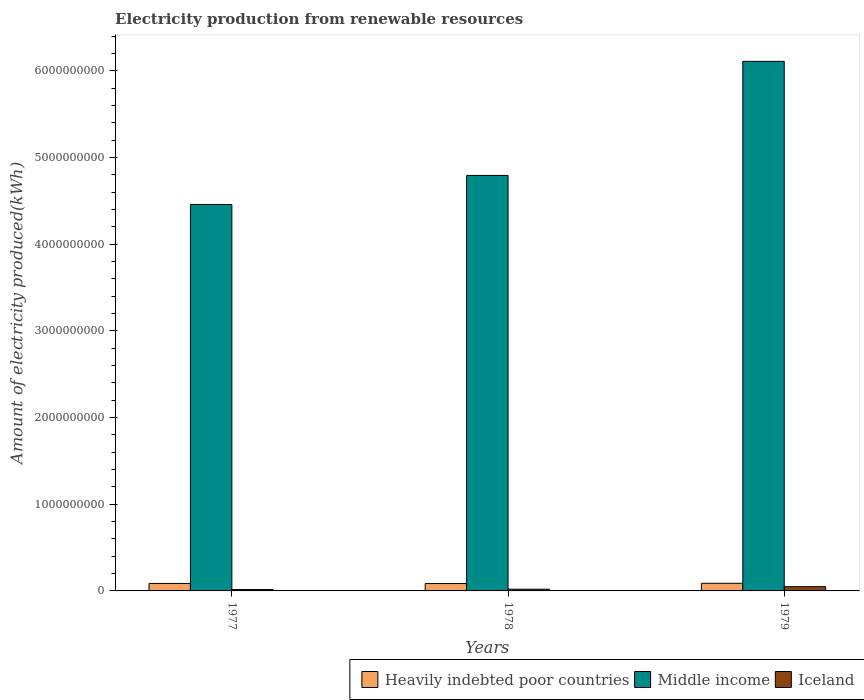What is the amount of electricity produced in Middle income in 1978?
Give a very brief answer. 4.79e+09. Across all years, what is the maximum amount of electricity produced in Iceland?
Provide a short and direct response. 4.90e+07. Across all years, what is the minimum amount of electricity produced in Middle income?
Your answer should be compact. 4.46e+09. In which year was the amount of electricity produced in Heavily indebted poor countries maximum?
Ensure brevity in your answer.  1979. In which year was the amount of electricity produced in Middle income minimum?
Ensure brevity in your answer.  1977. What is the total amount of electricity produced in Iceland in the graph?
Provide a succinct answer. 8.50e+07. What is the difference between the amount of electricity produced in Middle income in 1977 and that in 1979?
Give a very brief answer. -1.65e+09. What is the difference between the amount of electricity produced in Iceland in 1978 and the amount of electricity produced in Middle income in 1979?
Give a very brief answer. -6.09e+09. What is the average amount of electricity produced in Heavily indebted poor countries per year?
Your answer should be very brief. 8.63e+07. In the year 1979, what is the difference between the amount of electricity produced in Middle income and amount of electricity produced in Iceland?
Your answer should be very brief. 6.06e+09. What is the ratio of the amount of electricity produced in Heavily indebted poor countries in 1978 to that in 1979?
Provide a succinct answer. 0.97. Is the amount of electricity produced in Heavily indebted poor countries in 1978 less than that in 1979?
Provide a succinct answer. Yes. What is the difference between the highest and the second highest amount of electricity produced in Heavily indebted poor countries?
Offer a very short reply. 2.00e+06. What is the difference between the highest and the lowest amount of electricity produced in Iceland?
Your response must be concise. 3.30e+07. What does the 1st bar from the left in 1977 represents?
Offer a terse response. Heavily indebted poor countries. Is it the case that in every year, the sum of the amount of electricity produced in Iceland and amount of electricity produced in Heavily indebted poor countries is greater than the amount of electricity produced in Middle income?
Make the answer very short. No. Are all the bars in the graph horizontal?
Give a very brief answer. No. What is the difference between two consecutive major ticks on the Y-axis?
Offer a very short reply. 1.00e+09. Does the graph contain any zero values?
Provide a short and direct response. No. Does the graph contain grids?
Your answer should be compact. No. Where does the legend appear in the graph?
Your answer should be compact. Bottom right. How are the legend labels stacked?
Provide a succinct answer. Horizontal. What is the title of the graph?
Keep it short and to the point. Electricity production from renewable resources. What is the label or title of the Y-axis?
Offer a very short reply. Amount of electricity produced(kWh). What is the Amount of electricity produced(kWh) of Heavily indebted poor countries in 1977?
Offer a terse response. 8.60e+07. What is the Amount of electricity produced(kWh) of Middle income in 1977?
Make the answer very short. 4.46e+09. What is the Amount of electricity produced(kWh) of Iceland in 1977?
Make the answer very short. 1.60e+07. What is the Amount of electricity produced(kWh) in Heavily indebted poor countries in 1978?
Ensure brevity in your answer.  8.50e+07. What is the Amount of electricity produced(kWh) of Middle income in 1978?
Your answer should be very brief. 4.79e+09. What is the Amount of electricity produced(kWh) of Heavily indebted poor countries in 1979?
Your answer should be very brief. 8.80e+07. What is the Amount of electricity produced(kWh) in Middle income in 1979?
Ensure brevity in your answer.  6.11e+09. What is the Amount of electricity produced(kWh) in Iceland in 1979?
Make the answer very short. 4.90e+07. Across all years, what is the maximum Amount of electricity produced(kWh) in Heavily indebted poor countries?
Keep it short and to the point. 8.80e+07. Across all years, what is the maximum Amount of electricity produced(kWh) in Middle income?
Your answer should be compact. 6.11e+09. Across all years, what is the maximum Amount of electricity produced(kWh) in Iceland?
Provide a short and direct response. 4.90e+07. Across all years, what is the minimum Amount of electricity produced(kWh) in Heavily indebted poor countries?
Keep it short and to the point. 8.50e+07. Across all years, what is the minimum Amount of electricity produced(kWh) in Middle income?
Give a very brief answer. 4.46e+09. Across all years, what is the minimum Amount of electricity produced(kWh) in Iceland?
Provide a succinct answer. 1.60e+07. What is the total Amount of electricity produced(kWh) in Heavily indebted poor countries in the graph?
Your answer should be compact. 2.59e+08. What is the total Amount of electricity produced(kWh) in Middle income in the graph?
Make the answer very short. 1.54e+1. What is the total Amount of electricity produced(kWh) of Iceland in the graph?
Your answer should be compact. 8.50e+07. What is the difference between the Amount of electricity produced(kWh) in Middle income in 1977 and that in 1978?
Your answer should be compact. -3.35e+08. What is the difference between the Amount of electricity produced(kWh) in Heavily indebted poor countries in 1977 and that in 1979?
Provide a short and direct response. -2.00e+06. What is the difference between the Amount of electricity produced(kWh) of Middle income in 1977 and that in 1979?
Your answer should be very brief. -1.65e+09. What is the difference between the Amount of electricity produced(kWh) in Iceland in 1977 and that in 1979?
Offer a terse response. -3.30e+07. What is the difference between the Amount of electricity produced(kWh) of Middle income in 1978 and that in 1979?
Keep it short and to the point. -1.32e+09. What is the difference between the Amount of electricity produced(kWh) of Iceland in 1978 and that in 1979?
Your answer should be very brief. -2.90e+07. What is the difference between the Amount of electricity produced(kWh) of Heavily indebted poor countries in 1977 and the Amount of electricity produced(kWh) of Middle income in 1978?
Provide a short and direct response. -4.71e+09. What is the difference between the Amount of electricity produced(kWh) of Heavily indebted poor countries in 1977 and the Amount of electricity produced(kWh) of Iceland in 1978?
Offer a very short reply. 6.60e+07. What is the difference between the Amount of electricity produced(kWh) in Middle income in 1977 and the Amount of electricity produced(kWh) in Iceland in 1978?
Ensure brevity in your answer.  4.44e+09. What is the difference between the Amount of electricity produced(kWh) of Heavily indebted poor countries in 1977 and the Amount of electricity produced(kWh) of Middle income in 1979?
Offer a terse response. -6.02e+09. What is the difference between the Amount of electricity produced(kWh) in Heavily indebted poor countries in 1977 and the Amount of electricity produced(kWh) in Iceland in 1979?
Provide a succinct answer. 3.70e+07. What is the difference between the Amount of electricity produced(kWh) in Middle income in 1977 and the Amount of electricity produced(kWh) in Iceland in 1979?
Provide a succinct answer. 4.41e+09. What is the difference between the Amount of electricity produced(kWh) in Heavily indebted poor countries in 1978 and the Amount of electricity produced(kWh) in Middle income in 1979?
Make the answer very short. -6.02e+09. What is the difference between the Amount of electricity produced(kWh) of Heavily indebted poor countries in 1978 and the Amount of electricity produced(kWh) of Iceland in 1979?
Offer a very short reply. 3.60e+07. What is the difference between the Amount of electricity produced(kWh) in Middle income in 1978 and the Amount of electricity produced(kWh) in Iceland in 1979?
Ensure brevity in your answer.  4.74e+09. What is the average Amount of electricity produced(kWh) of Heavily indebted poor countries per year?
Keep it short and to the point. 8.63e+07. What is the average Amount of electricity produced(kWh) of Middle income per year?
Your response must be concise. 5.12e+09. What is the average Amount of electricity produced(kWh) in Iceland per year?
Your answer should be compact. 2.83e+07. In the year 1977, what is the difference between the Amount of electricity produced(kWh) in Heavily indebted poor countries and Amount of electricity produced(kWh) in Middle income?
Keep it short and to the point. -4.37e+09. In the year 1977, what is the difference between the Amount of electricity produced(kWh) in Heavily indebted poor countries and Amount of electricity produced(kWh) in Iceland?
Provide a succinct answer. 7.00e+07. In the year 1977, what is the difference between the Amount of electricity produced(kWh) in Middle income and Amount of electricity produced(kWh) in Iceland?
Ensure brevity in your answer.  4.44e+09. In the year 1978, what is the difference between the Amount of electricity produced(kWh) of Heavily indebted poor countries and Amount of electricity produced(kWh) of Middle income?
Your response must be concise. -4.71e+09. In the year 1978, what is the difference between the Amount of electricity produced(kWh) of Heavily indebted poor countries and Amount of electricity produced(kWh) of Iceland?
Your answer should be very brief. 6.50e+07. In the year 1978, what is the difference between the Amount of electricity produced(kWh) in Middle income and Amount of electricity produced(kWh) in Iceland?
Ensure brevity in your answer.  4.77e+09. In the year 1979, what is the difference between the Amount of electricity produced(kWh) in Heavily indebted poor countries and Amount of electricity produced(kWh) in Middle income?
Offer a very short reply. -6.02e+09. In the year 1979, what is the difference between the Amount of electricity produced(kWh) in Heavily indebted poor countries and Amount of electricity produced(kWh) in Iceland?
Give a very brief answer. 3.90e+07. In the year 1979, what is the difference between the Amount of electricity produced(kWh) of Middle income and Amount of electricity produced(kWh) of Iceland?
Keep it short and to the point. 6.06e+09. What is the ratio of the Amount of electricity produced(kWh) in Heavily indebted poor countries in 1977 to that in 1978?
Ensure brevity in your answer.  1.01. What is the ratio of the Amount of electricity produced(kWh) in Middle income in 1977 to that in 1978?
Provide a succinct answer. 0.93. What is the ratio of the Amount of electricity produced(kWh) in Heavily indebted poor countries in 1977 to that in 1979?
Your answer should be compact. 0.98. What is the ratio of the Amount of electricity produced(kWh) of Middle income in 1977 to that in 1979?
Your answer should be very brief. 0.73. What is the ratio of the Amount of electricity produced(kWh) of Iceland in 1977 to that in 1979?
Ensure brevity in your answer.  0.33. What is the ratio of the Amount of electricity produced(kWh) of Heavily indebted poor countries in 1978 to that in 1979?
Your answer should be compact. 0.97. What is the ratio of the Amount of electricity produced(kWh) in Middle income in 1978 to that in 1979?
Offer a terse response. 0.78. What is the ratio of the Amount of electricity produced(kWh) in Iceland in 1978 to that in 1979?
Provide a short and direct response. 0.41. What is the difference between the highest and the second highest Amount of electricity produced(kWh) in Heavily indebted poor countries?
Ensure brevity in your answer.  2.00e+06. What is the difference between the highest and the second highest Amount of electricity produced(kWh) of Middle income?
Give a very brief answer. 1.32e+09. What is the difference between the highest and the second highest Amount of electricity produced(kWh) in Iceland?
Provide a succinct answer. 2.90e+07. What is the difference between the highest and the lowest Amount of electricity produced(kWh) in Middle income?
Provide a short and direct response. 1.65e+09. What is the difference between the highest and the lowest Amount of electricity produced(kWh) in Iceland?
Offer a very short reply. 3.30e+07. 